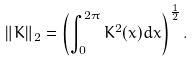<formula> <loc_0><loc_0><loc_500><loc_500>\| K \| _ { 2 } = \left ( \int _ { 0 } ^ { 2 \pi } { K ^ { 2 } ( x ) d x } \right ) ^ { \frac { 1 } { 2 } } .</formula> 